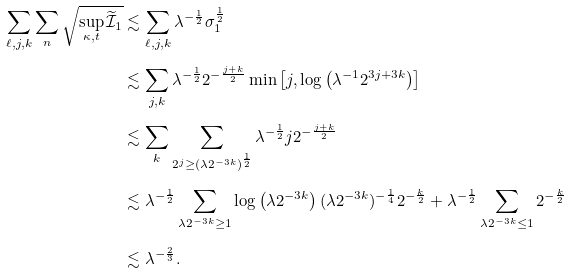Convert formula to latex. <formula><loc_0><loc_0><loc_500><loc_500>\sum _ { \ell , j , k } \sum _ { n } \sqrt { \sup _ { \kappa , t } \widetilde { \mathcal { I } } _ { 1 } } & \lesssim \sum _ { \ell , j , k } \lambda ^ { - \frac { 1 } { 2 } } \sigma _ { 1 } ^ { \frac { 1 } { 2 } } \\ & \lesssim \sum _ { j , k } \lambda ^ { - \frac { 1 } { 2 } } 2 ^ { - \frac { j + k } { 2 } } \min \left [ j , \log \left ( \lambda ^ { - 1 } 2 ^ { 3 j + 3 k } \right ) \right ] \\ & \lesssim \sum _ { k } \sum _ { 2 ^ { j } \geq ( \lambda 2 ^ { - 3 k } ) ^ { \frac { 1 } { 2 } } } \lambda ^ { - \frac { 1 } { 2 } } j 2 ^ { - \frac { j + k } { 2 } } \\ & \lesssim \lambda ^ { - \frac { 1 } { 2 } } \sum _ { \lambda 2 ^ { - 3 k } \geq 1 } \log \left ( \lambda 2 ^ { - 3 k } \right ) ( \lambda 2 ^ { - 3 k } ) ^ { - \frac { 1 } { 4 } } 2 ^ { - \frac { k } { 2 } } + \lambda ^ { - \frac { 1 } { 2 } } \sum _ { \lambda 2 ^ { - 3 k } \leq 1 } 2 ^ { - \frac { k } { 2 } } \\ & \lesssim \lambda ^ { - \frac { 2 } { 3 } } .</formula> 